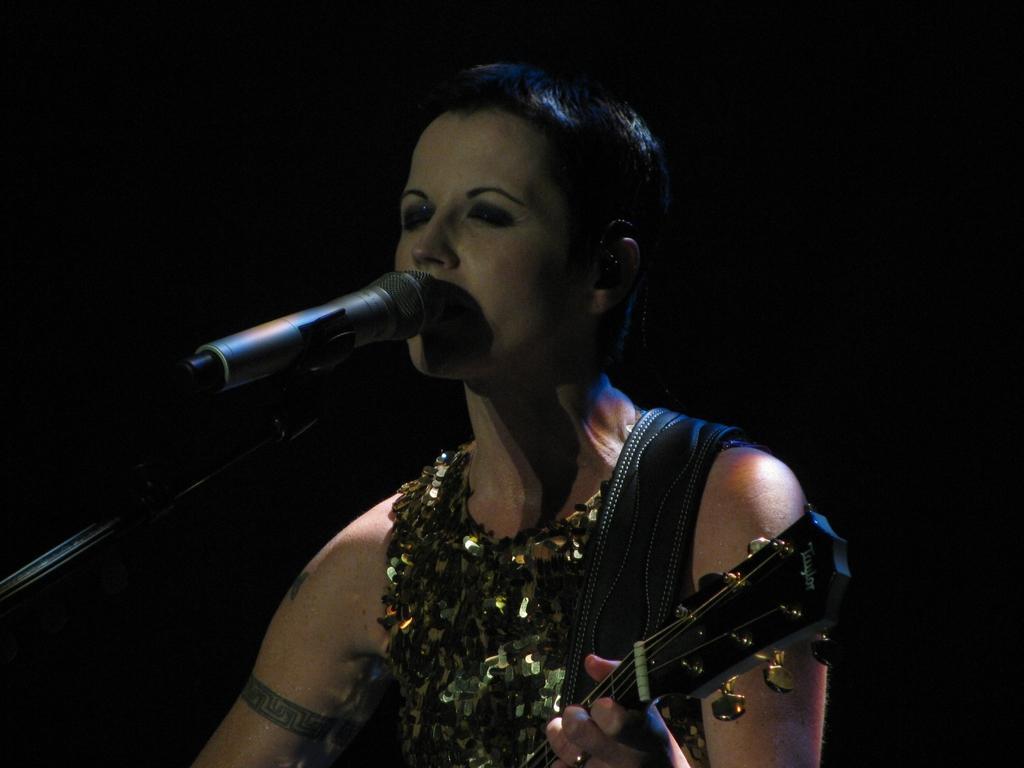How would you summarize this image in a sentence or two? In the image we can see there is a woman who is standing and holding guitar in her hand. 